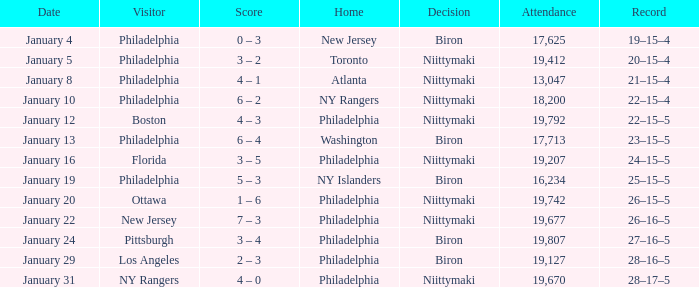On which date did niittymaki make the decision, with an attendance of more than 19,207 and a 28-17-5 record? January 31. 